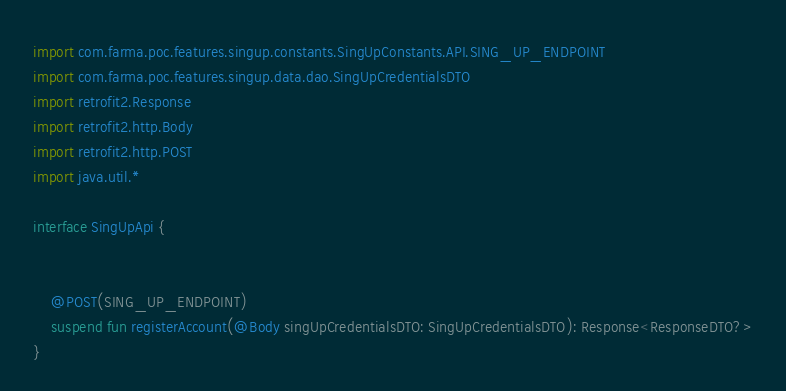Convert code to text. <code><loc_0><loc_0><loc_500><loc_500><_Kotlin_>import com.farma.poc.features.singup.constants.SingUpConstants.API.SING_UP_ENDPOINT
import com.farma.poc.features.singup.data.dao.SingUpCredentialsDTO
import retrofit2.Response
import retrofit2.http.Body
import retrofit2.http.POST
import java.util.*

interface SingUpApi {


    @POST(SING_UP_ENDPOINT)
    suspend fun registerAccount(@Body singUpCredentialsDTO: SingUpCredentialsDTO): Response<ResponseDTO?>
}</code> 